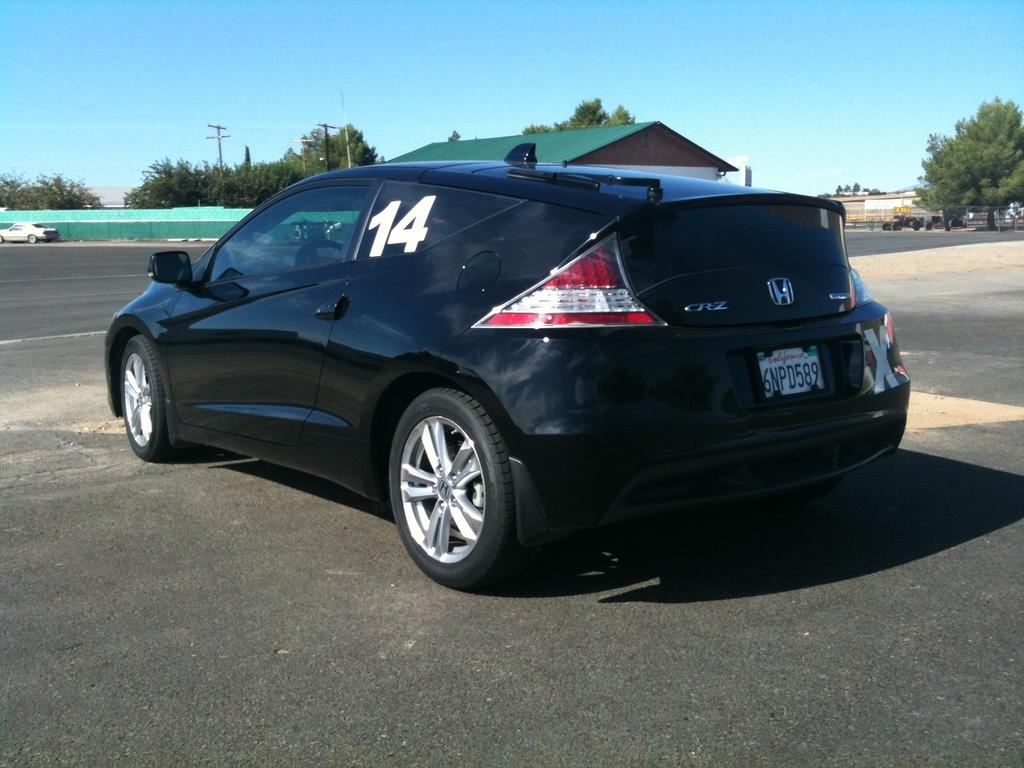What color is the car that is parked on the road in the image? The car that is parked on the road in the image is black. What other car can be seen in the image? There is a white car on the left side of the image. What can be seen in the background of the image? The background of the image includes walls, trees, houses, poles, and the sky. What current statement does the society make about the car in the image? There is no indication in the image of any current statement made by society about the car. 